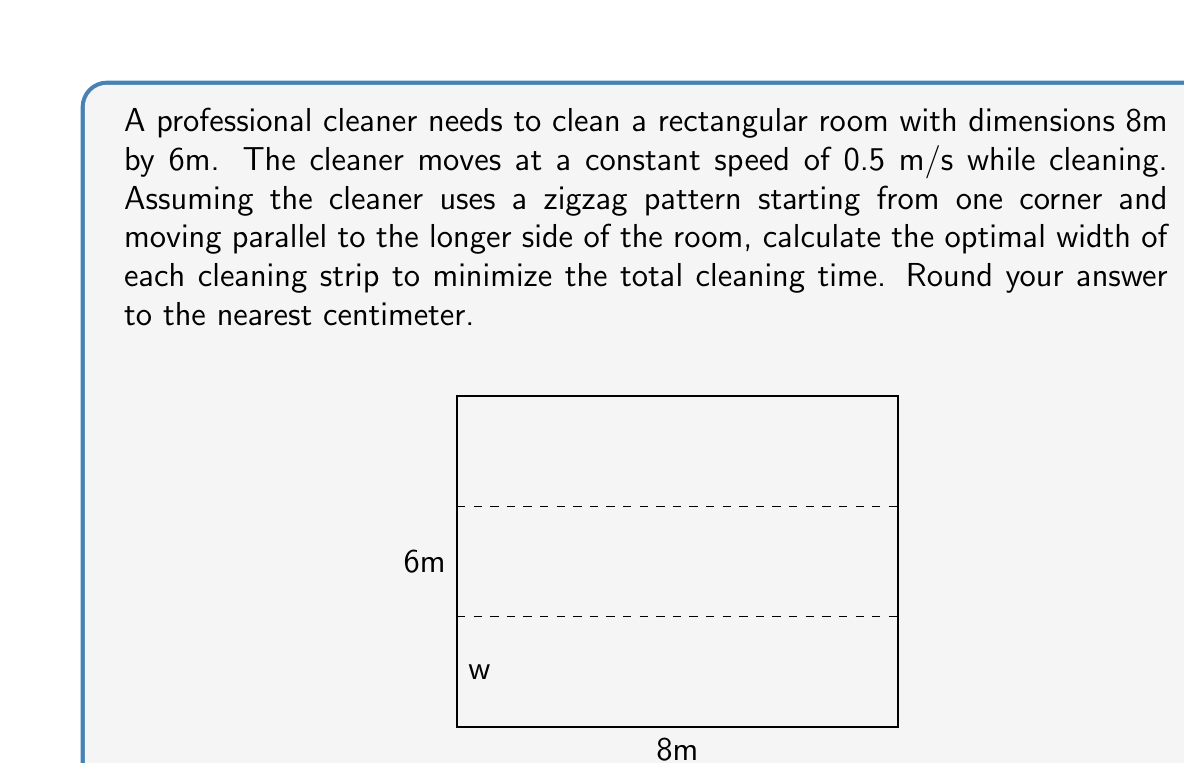Help me with this question. To solve this problem, we need to consider the time taken for cleaning and the time taken for turning at the end of each strip. Let's approach this step-by-step:

1) Let the width of each cleaning strip be $w$ meters.

2) The number of strips will be $n = \frac{6}{w}$.

3) The total distance traveled while cleaning will be:
   $$d_c = 8n = \frac{48}{w}$$

4) The number of turns will be $n-1 = \frac{6}{w} - 1$.

5) Assuming each turn takes 2 seconds, the total time for turns will be:
   $$t_t = 2(\frac{6}{w} - 1)$$

6) The total cleaning time will be:
   $$T = \frac{d_c}{v} + t_t = \frac{48}{0.5w} + 2(\frac{6}{w} - 1) = \frac{96}{w} + \frac{12}{w} - 2 = \frac{108}{w} - 2$$

7) To find the minimum time, we differentiate $T$ with respect to $w$ and set it to zero:
   $$\frac{dT}{dw} = -\frac{108}{w^2} = 0$$

8) This equation is satisfied when $w$ approaches infinity, which is not practical. In reality, there's a trade-off between the time saved by having fewer turns and the extra distance traveled due to overlapping.

9) A good rule of thumb in control theory for such problems is to choose a strip width that makes the turning time about 15% of the total time.

10) Let's set up this equation:
    $$\frac{2(\frac{6}{w} - 1)}{\frac{108}{w} - 2} = 0.15$$

11) Solving this equation:
    $$\frac{12 - 2w}{108 - 2w} = 0.15$$
    $$12 - 2w = 0.15(108 - 2w)$$
    $$12 - 2w = 16.2 - 0.3w$$
    $$-1.7w = 4.2$$
    $$w = 2.47$$

12) Rounding to the nearest centimeter gives us 2.47 m ≈ 2.47 m.
Answer: The optimal width of each cleaning strip is approximately 2.47 m or 247 cm. 